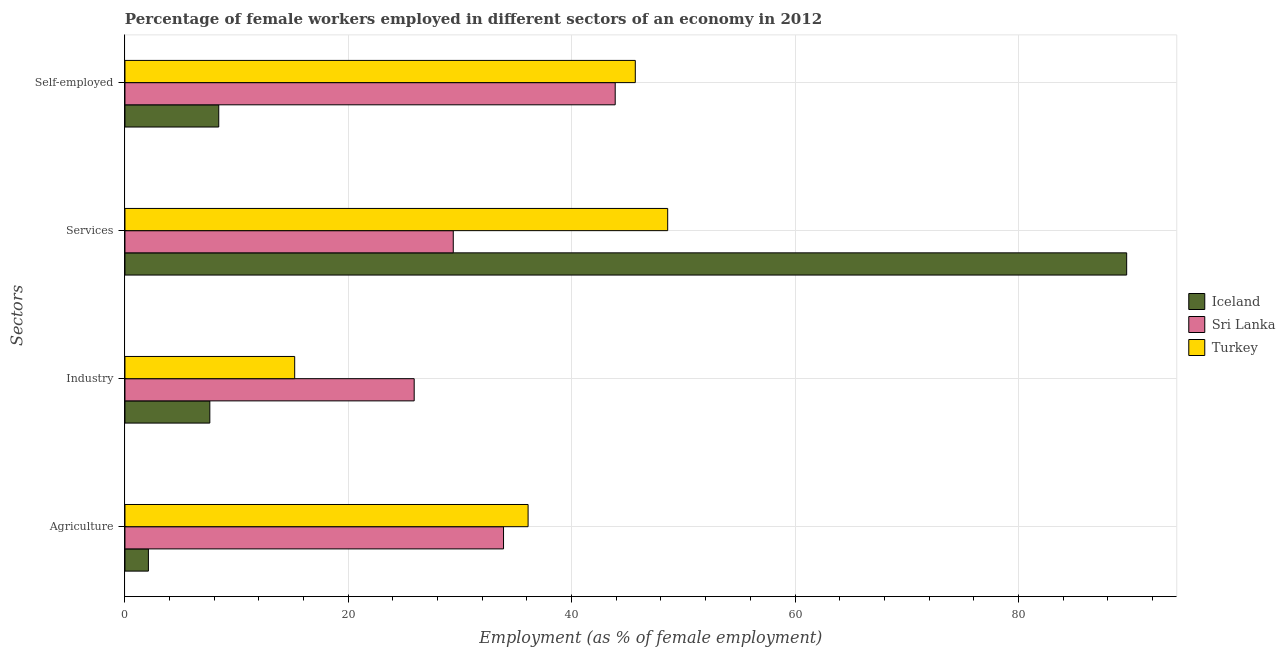How many different coloured bars are there?
Provide a short and direct response. 3. Are the number of bars per tick equal to the number of legend labels?
Offer a very short reply. Yes. How many bars are there on the 4th tick from the top?
Provide a short and direct response. 3. How many bars are there on the 3rd tick from the bottom?
Keep it short and to the point. 3. What is the label of the 3rd group of bars from the top?
Your response must be concise. Industry. What is the percentage of female workers in agriculture in Iceland?
Your response must be concise. 2.1. Across all countries, what is the maximum percentage of female workers in industry?
Make the answer very short. 25.9. Across all countries, what is the minimum percentage of self employed female workers?
Your answer should be compact. 8.4. In which country was the percentage of female workers in services maximum?
Provide a short and direct response. Iceland. What is the total percentage of female workers in industry in the graph?
Give a very brief answer. 48.7. What is the difference between the percentage of self employed female workers in Iceland and that in Turkey?
Your answer should be very brief. -37.3. What is the difference between the percentage of self employed female workers in Turkey and the percentage of female workers in services in Iceland?
Make the answer very short. -44. What is the average percentage of female workers in agriculture per country?
Provide a short and direct response. 24.03. What is the difference between the percentage of female workers in agriculture and percentage of female workers in services in Sri Lanka?
Your response must be concise. 4.5. What is the ratio of the percentage of self employed female workers in Turkey to that in Sri Lanka?
Provide a succinct answer. 1.04. Is the percentage of female workers in services in Iceland less than that in Turkey?
Your response must be concise. No. What is the difference between the highest and the second highest percentage of female workers in services?
Provide a short and direct response. 41.1. What is the difference between the highest and the lowest percentage of female workers in agriculture?
Offer a terse response. 34. In how many countries, is the percentage of female workers in services greater than the average percentage of female workers in services taken over all countries?
Provide a succinct answer. 1. What does the 2nd bar from the top in Industry represents?
Ensure brevity in your answer.  Sri Lanka. What does the 1st bar from the bottom in Services represents?
Offer a terse response. Iceland. Is it the case that in every country, the sum of the percentage of female workers in agriculture and percentage of female workers in industry is greater than the percentage of female workers in services?
Your answer should be very brief. No. How many bars are there?
Make the answer very short. 12. Are all the bars in the graph horizontal?
Offer a terse response. Yes. What is the difference between two consecutive major ticks on the X-axis?
Provide a succinct answer. 20. Does the graph contain any zero values?
Keep it short and to the point. No. Where does the legend appear in the graph?
Keep it short and to the point. Center right. How are the legend labels stacked?
Provide a short and direct response. Vertical. What is the title of the graph?
Your answer should be compact. Percentage of female workers employed in different sectors of an economy in 2012. Does "Honduras" appear as one of the legend labels in the graph?
Your answer should be compact. No. What is the label or title of the X-axis?
Ensure brevity in your answer.  Employment (as % of female employment). What is the label or title of the Y-axis?
Keep it short and to the point. Sectors. What is the Employment (as % of female employment) in Iceland in Agriculture?
Your answer should be compact. 2.1. What is the Employment (as % of female employment) in Sri Lanka in Agriculture?
Ensure brevity in your answer.  33.9. What is the Employment (as % of female employment) in Turkey in Agriculture?
Offer a terse response. 36.1. What is the Employment (as % of female employment) in Iceland in Industry?
Ensure brevity in your answer.  7.6. What is the Employment (as % of female employment) in Sri Lanka in Industry?
Your response must be concise. 25.9. What is the Employment (as % of female employment) in Turkey in Industry?
Provide a succinct answer. 15.2. What is the Employment (as % of female employment) of Iceland in Services?
Ensure brevity in your answer.  89.7. What is the Employment (as % of female employment) of Sri Lanka in Services?
Offer a very short reply. 29.4. What is the Employment (as % of female employment) in Turkey in Services?
Ensure brevity in your answer.  48.6. What is the Employment (as % of female employment) of Iceland in Self-employed?
Keep it short and to the point. 8.4. What is the Employment (as % of female employment) of Sri Lanka in Self-employed?
Your answer should be compact. 43.9. What is the Employment (as % of female employment) in Turkey in Self-employed?
Offer a terse response. 45.7. Across all Sectors, what is the maximum Employment (as % of female employment) in Iceland?
Make the answer very short. 89.7. Across all Sectors, what is the maximum Employment (as % of female employment) of Sri Lanka?
Give a very brief answer. 43.9. Across all Sectors, what is the maximum Employment (as % of female employment) of Turkey?
Your answer should be compact. 48.6. Across all Sectors, what is the minimum Employment (as % of female employment) of Iceland?
Keep it short and to the point. 2.1. Across all Sectors, what is the minimum Employment (as % of female employment) in Sri Lanka?
Offer a terse response. 25.9. Across all Sectors, what is the minimum Employment (as % of female employment) of Turkey?
Your answer should be compact. 15.2. What is the total Employment (as % of female employment) in Iceland in the graph?
Offer a very short reply. 107.8. What is the total Employment (as % of female employment) in Sri Lanka in the graph?
Give a very brief answer. 133.1. What is the total Employment (as % of female employment) of Turkey in the graph?
Provide a short and direct response. 145.6. What is the difference between the Employment (as % of female employment) in Iceland in Agriculture and that in Industry?
Give a very brief answer. -5.5. What is the difference between the Employment (as % of female employment) in Turkey in Agriculture and that in Industry?
Your answer should be very brief. 20.9. What is the difference between the Employment (as % of female employment) of Iceland in Agriculture and that in Services?
Provide a short and direct response. -87.6. What is the difference between the Employment (as % of female employment) in Sri Lanka in Agriculture and that in Services?
Offer a terse response. 4.5. What is the difference between the Employment (as % of female employment) in Sri Lanka in Agriculture and that in Self-employed?
Keep it short and to the point. -10. What is the difference between the Employment (as % of female employment) in Turkey in Agriculture and that in Self-employed?
Keep it short and to the point. -9.6. What is the difference between the Employment (as % of female employment) in Iceland in Industry and that in Services?
Your answer should be compact. -82.1. What is the difference between the Employment (as % of female employment) in Turkey in Industry and that in Services?
Provide a short and direct response. -33.4. What is the difference between the Employment (as % of female employment) of Sri Lanka in Industry and that in Self-employed?
Provide a short and direct response. -18. What is the difference between the Employment (as % of female employment) in Turkey in Industry and that in Self-employed?
Provide a succinct answer. -30.5. What is the difference between the Employment (as % of female employment) in Iceland in Services and that in Self-employed?
Offer a very short reply. 81.3. What is the difference between the Employment (as % of female employment) of Turkey in Services and that in Self-employed?
Make the answer very short. 2.9. What is the difference between the Employment (as % of female employment) in Iceland in Agriculture and the Employment (as % of female employment) in Sri Lanka in Industry?
Provide a short and direct response. -23.8. What is the difference between the Employment (as % of female employment) of Iceland in Agriculture and the Employment (as % of female employment) of Sri Lanka in Services?
Provide a succinct answer. -27.3. What is the difference between the Employment (as % of female employment) of Iceland in Agriculture and the Employment (as % of female employment) of Turkey in Services?
Keep it short and to the point. -46.5. What is the difference between the Employment (as % of female employment) in Sri Lanka in Agriculture and the Employment (as % of female employment) in Turkey in Services?
Give a very brief answer. -14.7. What is the difference between the Employment (as % of female employment) of Iceland in Agriculture and the Employment (as % of female employment) of Sri Lanka in Self-employed?
Keep it short and to the point. -41.8. What is the difference between the Employment (as % of female employment) in Iceland in Agriculture and the Employment (as % of female employment) in Turkey in Self-employed?
Offer a terse response. -43.6. What is the difference between the Employment (as % of female employment) in Sri Lanka in Agriculture and the Employment (as % of female employment) in Turkey in Self-employed?
Keep it short and to the point. -11.8. What is the difference between the Employment (as % of female employment) in Iceland in Industry and the Employment (as % of female employment) in Sri Lanka in Services?
Give a very brief answer. -21.8. What is the difference between the Employment (as % of female employment) in Iceland in Industry and the Employment (as % of female employment) in Turkey in Services?
Provide a short and direct response. -41. What is the difference between the Employment (as % of female employment) of Sri Lanka in Industry and the Employment (as % of female employment) of Turkey in Services?
Ensure brevity in your answer.  -22.7. What is the difference between the Employment (as % of female employment) in Iceland in Industry and the Employment (as % of female employment) in Sri Lanka in Self-employed?
Make the answer very short. -36.3. What is the difference between the Employment (as % of female employment) of Iceland in Industry and the Employment (as % of female employment) of Turkey in Self-employed?
Provide a short and direct response. -38.1. What is the difference between the Employment (as % of female employment) of Sri Lanka in Industry and the Employment (as % of female employment) of Turkey in Self-employed?
Provide a short and direct response. -19.8. What is the difference between the Employment (as % of female employment) in Iceland in Services and the Employment (as % of female employment) in Sri Lanka in Self-employed?
Your answer should be compact. 45.8. What is the difference between the Employment (as % of female employment) in Iceland in Services and the Employment (as % of female employment) in Turkey in Self-employed?
Your response must be concise. 44. What is the difference between the Employment (as % of female employment) in Sri Lanka in Services and the Employment (as % of female employment) in Turkey in Self-employed?
Keep it short and to the point. -16.3. What is the average Employment (as % of female employment) in Iceland per Sectors?
Offer a very short reply. 26.95. What is the average Employment (as % of female employment) in Sri Lanka per Sectors?
Your answer should be compact. 33.27. What is the average Employment (as % of female employment) of Turkey per Sectors?
Ensure brevity in your answer.  36.4. What is the difference between the Employment (as % of female employment) of Iceland and Employment (as % of female employment) of Sri Lanka in Agriculture?
Your answer should be compact. -31.8. What is the difference between the Employment (as % of female employment) of Iceland and Employment (as % of female employment) of Turkey in Agriculture?
Offer a very short reply. -34. What is the difference between the Employment (as % of female employment) of Sri Lanka and Employment (as % of female employment) of Turkey in Agriculture?
Ensure brevity in your answer.  -2.2. What is the difference between the Employment (as % of female employment) in Iceland and Employment (as % of female employment) in Sri Lanka in Industry?
Provide a short and direct response. -18.3. What is the difference between the Employment (as % of female employment) in Iceland and Employment (as % of female employment) in Turkey in Industry?
Your answer should be very brief. -7.6. What is the difference between the Employment (as % of female employment) of Iceland and Employment (as % of female employment) of Sri Lanka in Services?
Offer a terse response. 60.3. What is the difference between the Employment (as % of female employment) of Iceland and Employment (as % of female employment) of Turkey in Services?
Your answer should be very brief. 41.1. What is the difference between the Employment (as % of female employment) of Sri Lanka and Employment (as % of female employment) of Turkey in Services?
Ensure brevity in your answer.  -19.2. What is the difference between the Employment (as % of female employment) of Iceland and Employment (as % of female employment) of Sri Lanka in Self-employed?
Your response must be concise. -35.5. What is the difference between the Employment (as % of female employment) in Iceland and Employment (as % of female employment) in Turkey in Self-employed?
Provide a succinct answer. -37.3. What is the difference between the Employment (as % of female employment) of Sri Lanka and Employment (as % of female employment) of Turkey in Self-employed?
Your answer should be very brief. -1.8. What is the ratio of the Employment (as % of female employment) of Iceland in Agriculture to that in Industry?
Give a very brief answer. 0.28. What is the ratio of the Employment (as % of female employment) of Sri Lanka in Agriculture to that in Industry?
Ensure brevity in your answer.  1.31. What is the ratio of the Employment (as % of female employment) in Turkey in Agriculture to that in Industry?
Offer a terse response. 2.38. What is the ratio of the Employment (as % of female employment) of Iceland in Agriculture to that in Services?
Offer a very short reply. 0.02. What is the ratio of the Employment (as % of female employment) in Sri Lanka in Agriculture to that in Services?
Your answer should be compact. 1.15. What is the ratio of the Employment (as % of female employment) in Turkey in Agriculture to that in Services?
Give a very brief answer. 0.74. What is the ratio of the Employment (as % of female employment) of Sri Lanka in Agriculture to that in Self-employed?
Make the answer very short. 0.77. What is the ratio of the Employment (as % of female employment) of Turkey in Agriculture to that in Self-employed?
Your answer should be very brief. 0.79. What is the ratio of the Employment (as % of female employment) of Iceland in Industry to that in Services?
Your response must be concise. 0.08. What is the ratio of the Employment (as % of female employment) of Sri Lanka in Industry to that in Services?
Keep it short and to the point. 0.88. What is the ratio of the Employment (as % of female employment) of Turkey in Industry to that in Services?
Your answer should be very brief. 0.31. What is the ratio of the Employment (as % of female employment) in Iceland in Industry to that in Self-employed?
Your response must be concise. 0.9. What is the ratio of the Employment (as % of female employment) in Sri Lanka in Industry to that in Self-employed?
Offer a terse response. 0.59. What is the ratio of the Employment (as % of female employment) in Turkey in Industry to that in Self-employed?
Your answer should be compact. 0.33. What is the ratio of the Employment (as % of female employment) in Iceland in Services to that in Self-employed?
Give a very brief answer. 10.68. What is the ratio of the Employment (as % of female employment) of Sri Lanka in Services to that in Self-employed?
Your response must be concise. 0.67. What is the ratio of the Employment (as % of female employment) of Turkey in Services to that in Self-employed?
Provide a short and direct response. 1.06. What is the difference between the highest and the second highest Employment (as % of female employment) of Iceland?
Offer a very short reply. 81.3. What is the difference between the highest and the lowest Employment (as % of female employment) in Iceland?
Your response must be concise. 87.6. What is the difference between the highest and the lowest Employment (as % of female employment) of Sri Lanka?
Give a very brief answer. 18. What is the difference between the highest and the lowest Employment (as % of female employment) in Turkey?
Provide a succinct answer. 33.4. 